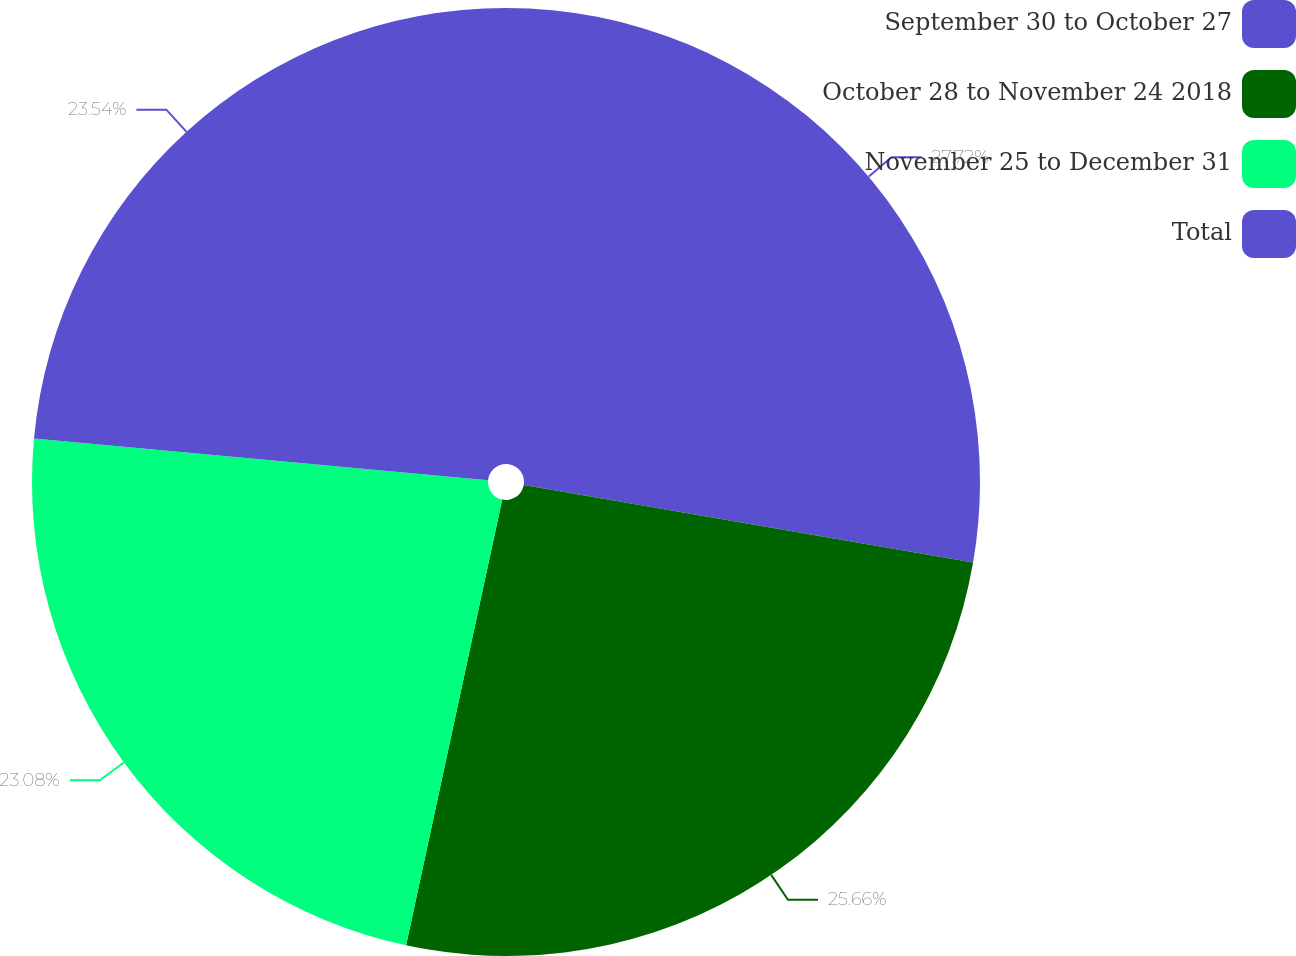<chart> <loc_0><loc_0><loc_500><loc_500><pie_chart><fcel>September 30 to October 27<fcel>October 28 to November 24 2018<fcel>November 25 to December 31<fcel>Total<nl><fcel>27.72%<fcel>25.66%<fcel>23.08%<fcel>23.54%<nl></chart> 